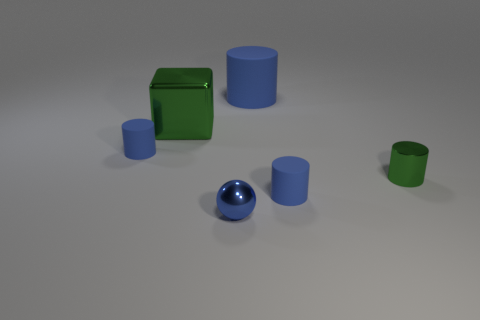Is there any other thing that is the same shape as the small blue metal object?
Give a very brief answer. No. There is a large green thing that is made of the same material as the small ball; what shape is it?
Provide a succinct answer. Cube. There is a metal thing left of the blue metal object; is it the same size as the big blue matte thing?
Your answer should be compact. Yes. How many things are green metallic objects that are on the left side of the large blue rubber thing or things on the left side of the metal block?
Make the answer very short. 2. Is the color of the large object to the left of the big blue cylinder the same as the small metal cylinder?
Make the answer very short. Yes. What number of matte objects are blue blocks or tiny balls?
Provide a succinct answer. 0. What shape is the big shiny thing?
Offer a very short reply. Cube. Is the material of the big cylinder the same as the green block?
Offer a terse response. No. There is a small blue cylinder that is left of the big thing on the left side of the tiny ball; are there any metallic cylinders behind it?
Offer a terse response. No. What number of other things are there of the same shape as the big green shiny object?
Your answer should be compact. 0. 